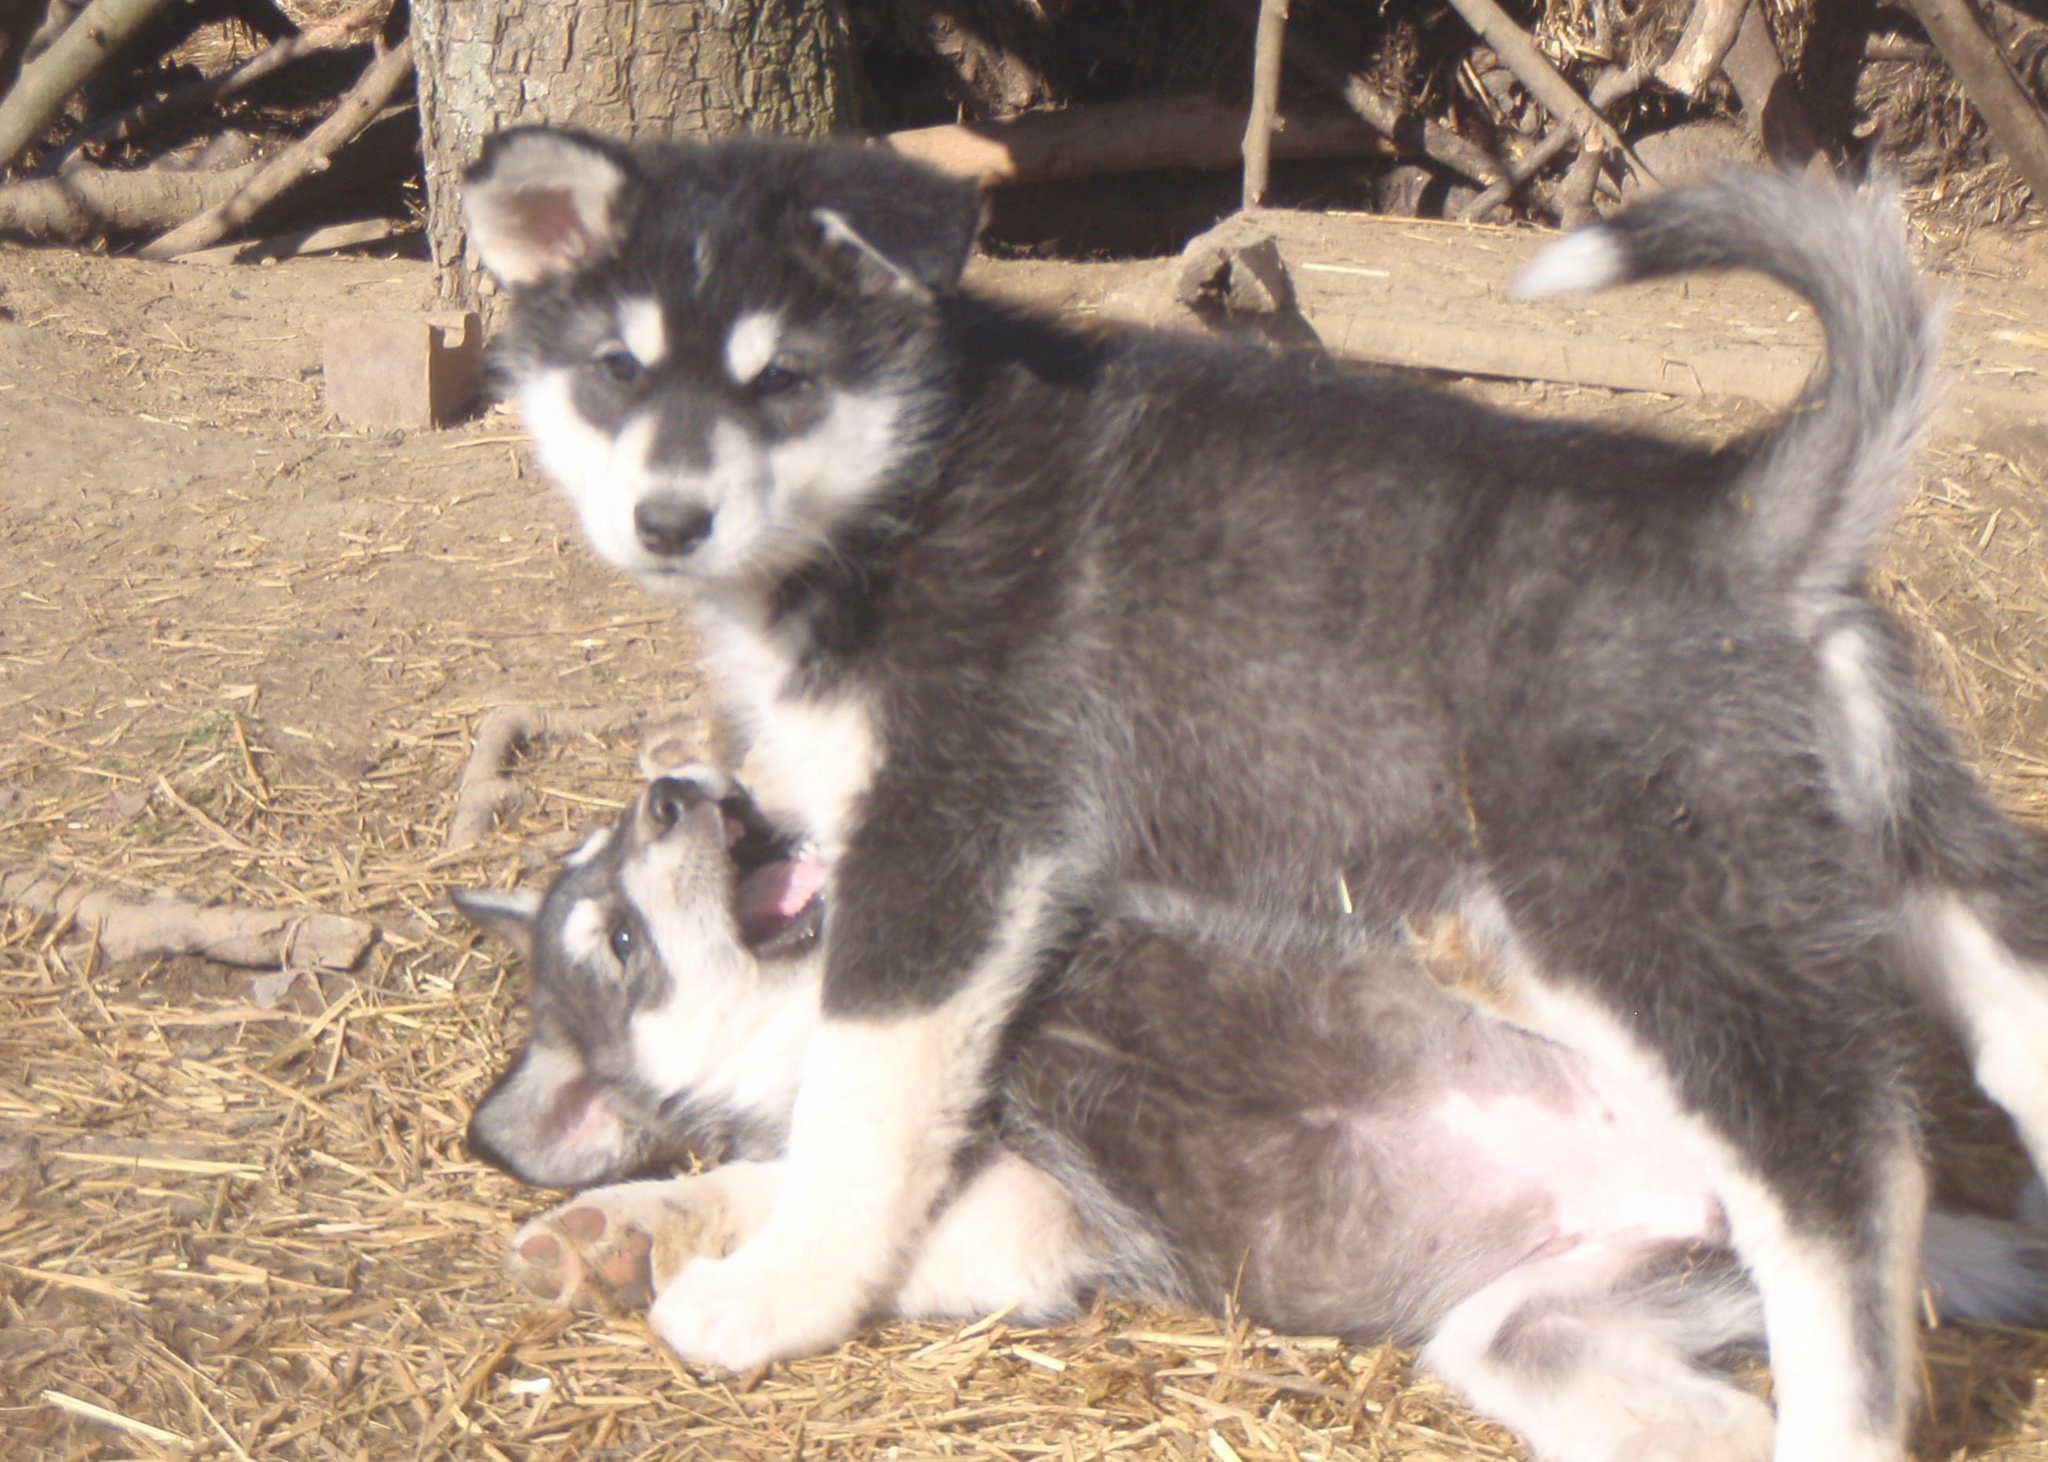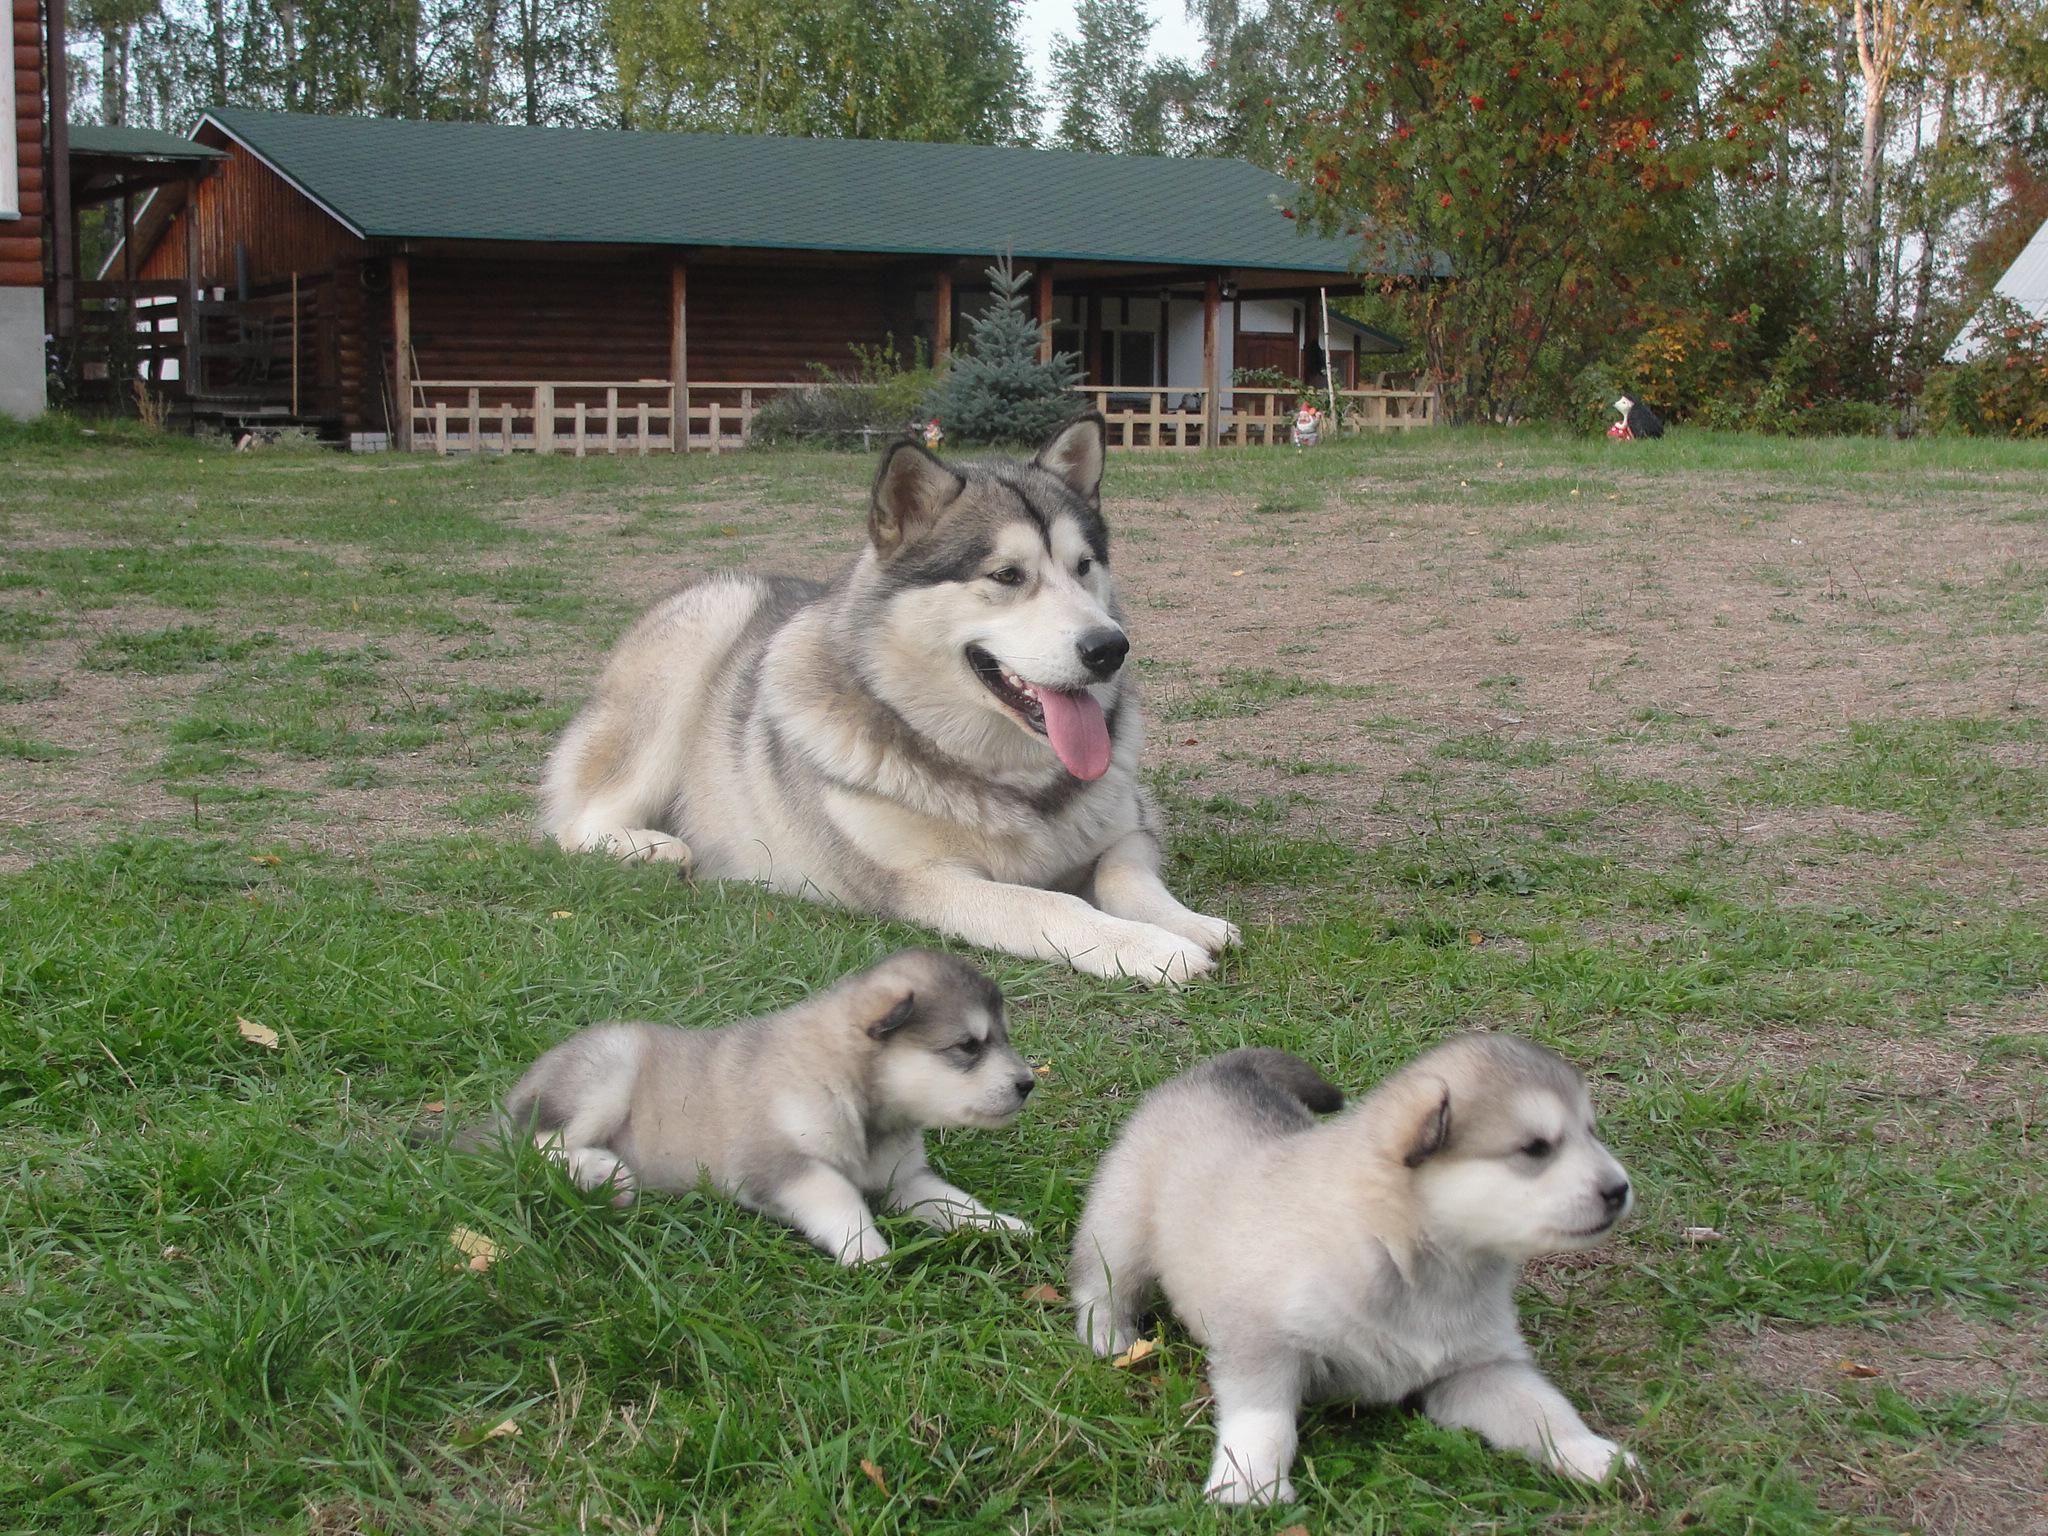The first image is the image on the left, the second image is the image on the right. Considering the images on both sides, is "A dog has its tongue out." valid? Answer yes or no. Yes. The first image is the image on the left, the second image is the image on the right. Given the left and right images, does the statement "There are exactly two dogs in total." hold true? Answer yes or no. No. 